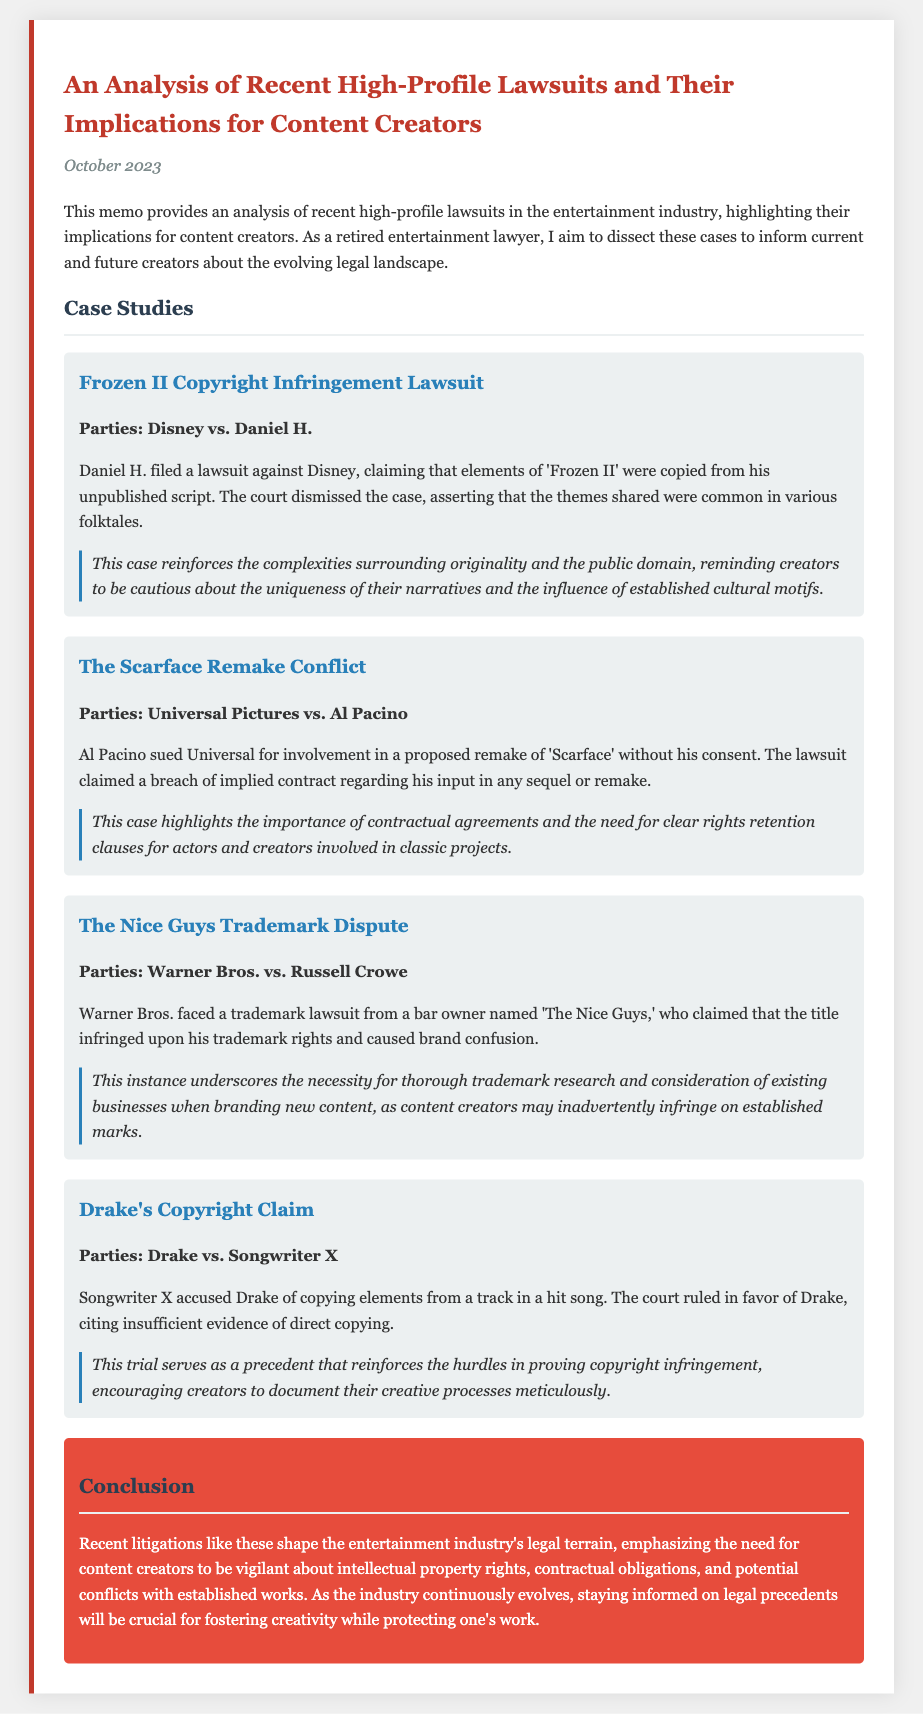What is the title of the memo? The title of the memo is stated at the beginning of the document.
Answer: An Analysis of Recent High-Profile Lawsuits and Their Implications for Content Creators Who is involved in the Frozen II lawsuit? The memo lists the parties involved in the Frozen II lawsuit.
Answer: Disney vs. Daniel H What did Al Pacino sue Universal Pictures for? The memo explains the basis of Al Pacino's lawsuit in relation to a proposed remake.
Answer: Breach of implied contract What is the main implication of The Nice Guys trademark dispute? The implications section provides insights into the lessons from the trademark dispute with Warner Bros.
Answer: Necessity for thorough trademark research Who accused Drake of copyright infringement? The memo identifies the party that filed a claim against Drake.
Answer: Songwriter X What should content creators document according to the memo? The conclusion suggests practices for content creators to follow.
Answer: Their creative processes Which month and year was this memo published? The date of the memo is clearly mentioned at the top of the document.
Answer: October 2023 What color is associated with the conclusion section of the memo? The style elements for the conclusion are described in the document.
Answer: Red What does the memo emphasize for content creators? The conclusion summarizes the key takeaway for creators in the industry.
Answer: Vigilance about intellectual property rights 